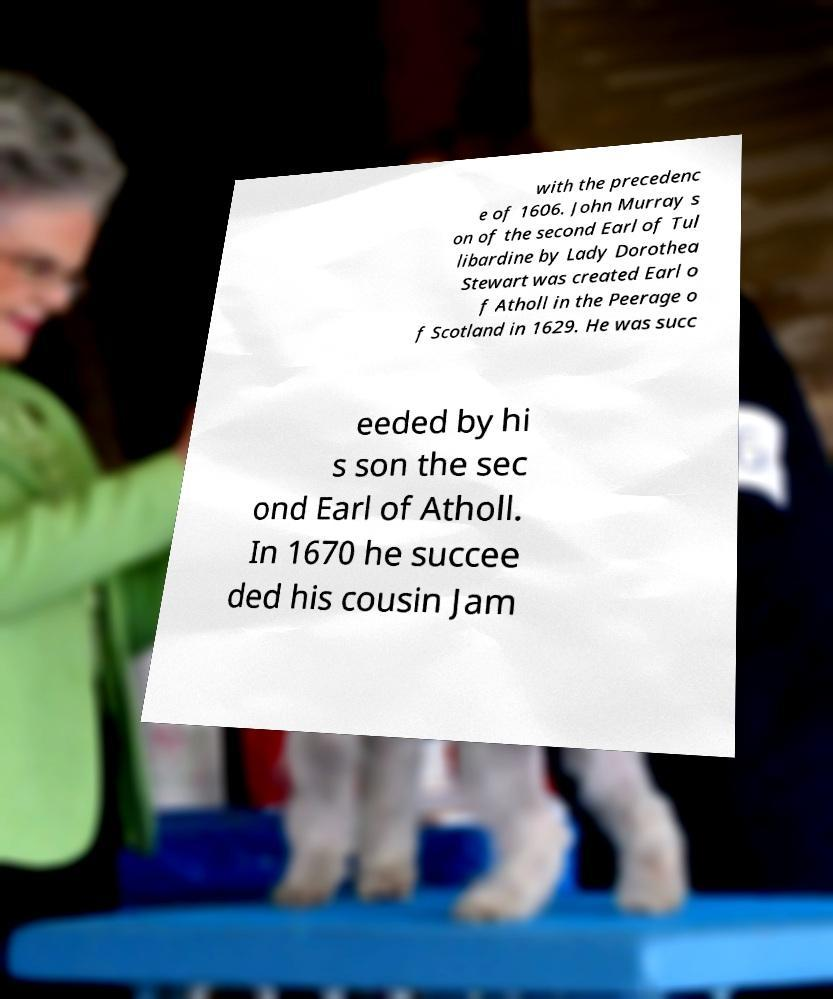There's text embedded in this image that I need extracted. Can you transcribe it verbatim? with the precedenc e of 1606. John Murray s on of the second Earl of Tul libardine by Lady Dorothea Stewart was created Earl o f Atholl in the Peerage o f Scotland in 1629. He was succ eeded by hi s son the sec ond Earl of Atholl. In 1670 he succee ded his cousin Jam 